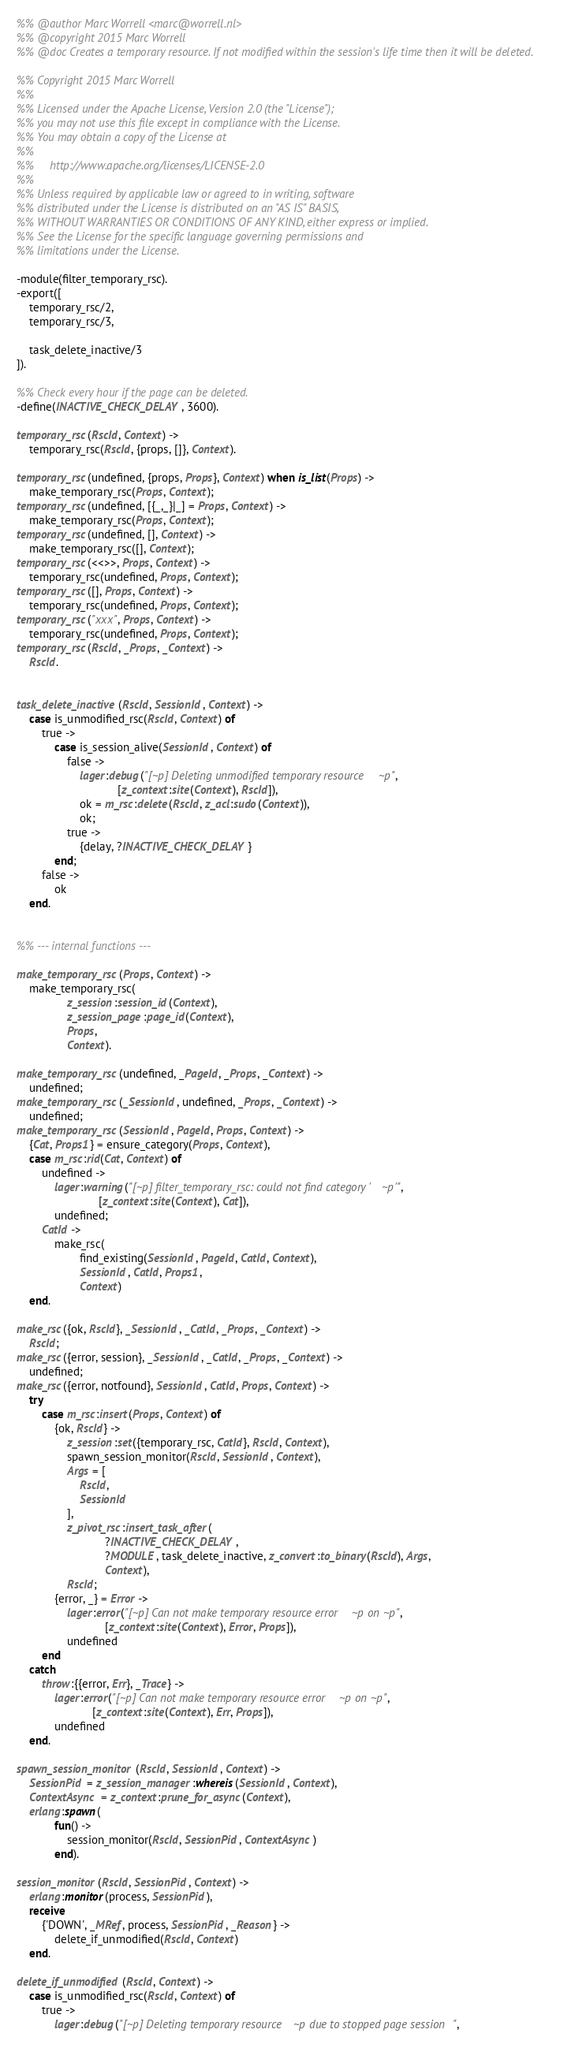Convert code to text. <code><loc_0><loc_0><loc_500><loc_500><_Erlang_>%% @author Marc Worrell <marc@worrell.nl>
%% @copyright 2015 Marc Worrell
%% @doc Creates a temporary resource. If not modified within the session's life time then it will be deleted.

%% Copyright 2015 Marc Worrell
%%
%% Licensed under the Apache License, Version 2.0 (the "License");
%% you may not use this file except in compliance with the License.
%% You may obtain a copy of the License at
%% 
%%     http://www.apache.org/licenses/LICENSE-2.0
%% 
%% Unless required by applicable law or agreed to in writing, software
%% distributed under the License is distributed on an "AS IS" BASIS,
%% WITHOUT WARRANTIES OR CONDITIONS OF ANY KIND, either express or implied.
%% See the License for the specific language governing permissions and
%% limitations under the License.

-module(filter_temporary_rsc).
-export([
    temporary_rsc/2, 
    temporary_rsc/3,

    task_delete_inactive/3
]).

%% Check every hour if the page can be deleted.
-define(INACTIVE_CHECK_DELAY, 3600).

temporary_rsc(RscId, Context) ->
    temporary_rsc(RscId, {props, []}, Context).

temporary_rsc(undefined, {props, Props}, Context) when is_list(Props) ->
    make_temporary_rsc(Props, Context);
temporary_rsc(undefined, [{_,_}|_] = Props, Context) ->
    make_temporary_rsc(Props, Context);
temporary_rsc(undefined, [], Context) ->
    make_temporary_rsc([], Context);
temporary_rsc(<<>>, Props, Context) ->
    temporary_rsc(undefined, Props, Context);
temporary_rsc([], Props, Context) ->
    temporary_rsc(undefined, Props, Context);
temporary_rsc("xxx", Props, Context) ->
    temporary_rsc(undefined, Props, Context);
temporary_rsc(RscId, _Props, _Context) ->
    RscId.


task_delete_inactive(RscId, SessionId, Context) ->
    case is_unmodified_rsc(RscId, Context) of
        true ->
            case is_session_alive(SessionId, Context) of
                false ->
                    lager:debug("[~p] Deleting unmodified temporary resource ~p", 
                                [z_context:site(Context), RscId]),
                    ok = m_rsc:delete(RscId, z_acl:sudo(Context)),
                    ok;
                true ->
                    {delay, ?INACTIVE_CHECK_DELAY}
            end;
        false ->
            ok
    end.


%% --- internal functions ---

make_temporary_rsc(Props, Context) ->
    make_temporary_rsc(
                z_session:session_id(Context),
                z_session_page:page_id(Context), 
                Props, 
                Context).

make_temporary_rsc(undefined, _PageId, _Props, _Context) ->
    undefined;
make_temporary_rsc(_SessionId, undefined, _Props, _Context) ->
    undefined;
make_temporary_rsc(SessionId, PageId, Props, Context) ->
    {Cat, Props1} = ensure_category(Props, Context),
    case m_rsc:rid(Cat, Context) of
        undefined ->
            lager:warning("[~p] filter_temporary_rsc: could not find category '~p'", 
                          [z_context:site(Context), Cat]),
            undefined;
        CatId ->
            make_rsc(
                    find_existing(SessionId, PageId, CatId, Context), 
                    SessionId, CatId, Props1, 
                    Context)
    end.

make_rsc({ok, RscId}, _SessionId, _CatId, _Props, _Context) ->
    RscId;
make_rsc({error, session}, _SessionId, _CatId, _Props, _Context) ->
    undefined;
make_rsc({error, notfound}, SessionId, CatId, Props, Context) ->
    try
        case m_rsc:insert(Props, Context) of
            {ok, RscId} ->
                z_session:set({temporary_rsc, CatId}, RscId, Context),
                spawn_session_monitor(RscId, SessionId, Context),
                Args = [
                    RscId,
                    SessionId
                ],
                z_pivot_rsc:insert_task_after(
                            ?INACTIVE_CHECK_DELAY,
                            ?MODULE, task_delete_inactive, z_convert:to_binary(RscId), Args,
                            Context),
                RscId;
            {error, _} = Error ->
                lager:error("[~p] Can not make temporary resource error ~p on ~p", 
                            [z_context:site(Context), Error, Props]),
                undefined
        end
    catch
        throw:{{error, Err}, _Trace} ->
            lager:error("[~p] Can not make temporary resource error ~p on ~p", 
                        [z_context:site(Context), Err, Props]),
            undefined
    end.

spawn_session_monitor(RscId, SessionId, Context) ->
    SessionPid = z_session_manager:whereis(SessionId, Context),
    ContextAsync = z_context:prune_for_async(Context),
    erlang:spawn(
            fun() ->
                session_monitor(RscId, SessionPid, ContextAsync)
            end).

session_monitor(RscId, SessionPid, Context) ->
    erlang:monitor(process, SessionPid),
    receive
        {'DOWN', _MRef, process, SessionPid, _Reason} ->
            delete_if_unmodified(RscId, Context)
    end.

delete_if_unmodified(RscId, Context) ->
    case is_unmodified_rsc(RscId, Context) of
        true ->
            lager:debug("[~p] Deleting temporary resource ~p due to stopped page session",</code> 